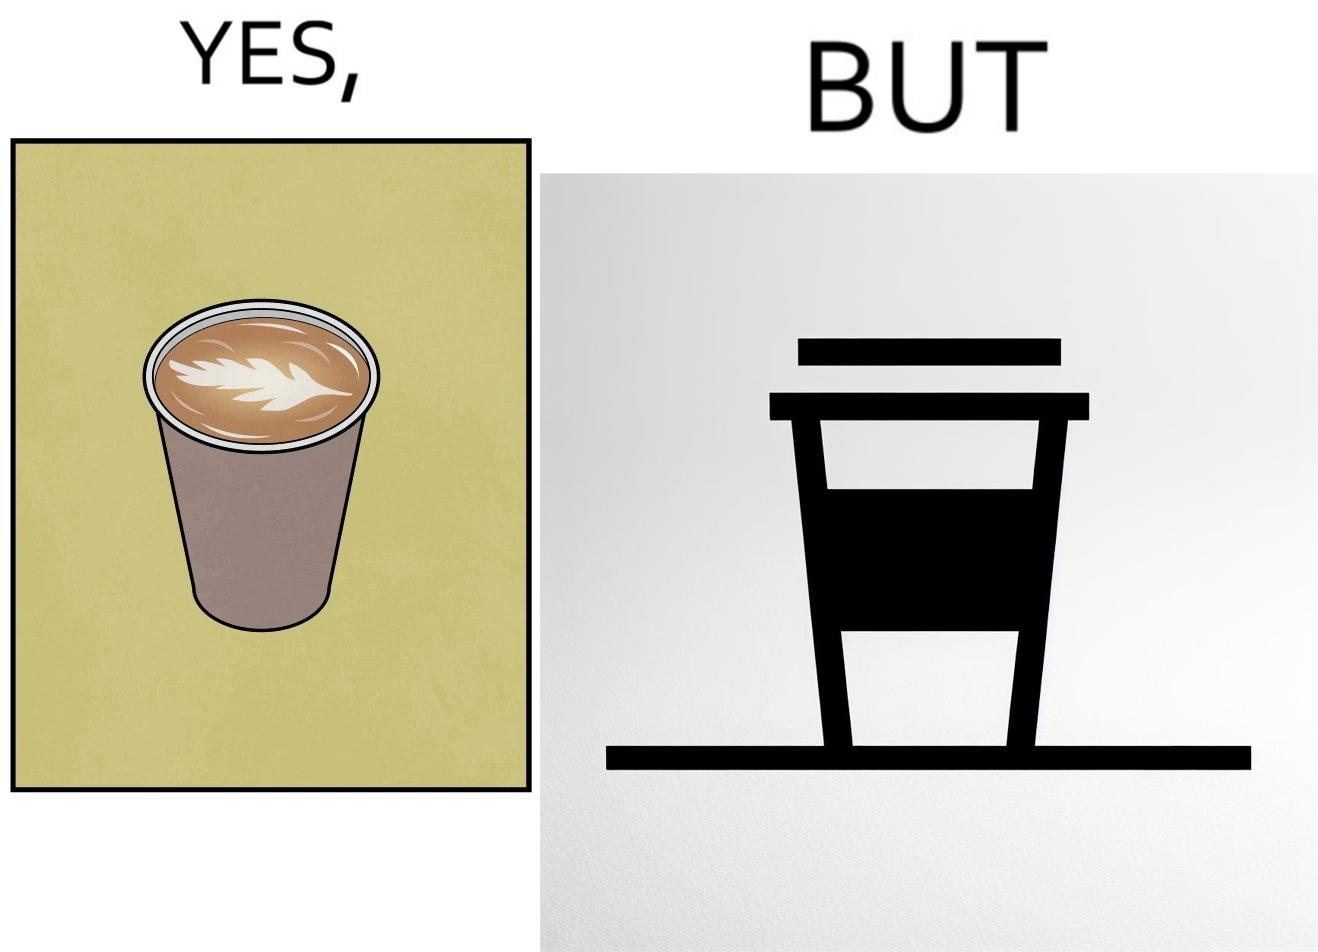Is this image satirical or non-satirical? Yes, this image is satirical. 